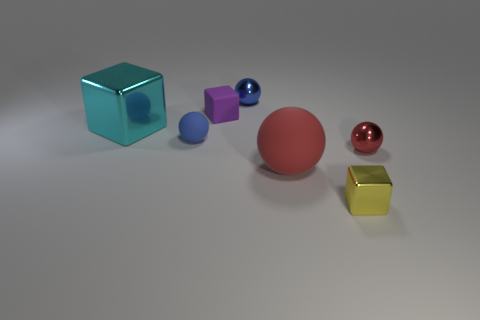Which object stands out the most to you? The red sphere stands out prominently due to its vibrant color and larger size relative to the other objects. Do the objects have textures that make them look realistic? Yes, the objects have reflective, metallic textures that give them a realistic appearance, suggesting they are made of materials such as metal or polished stone. 